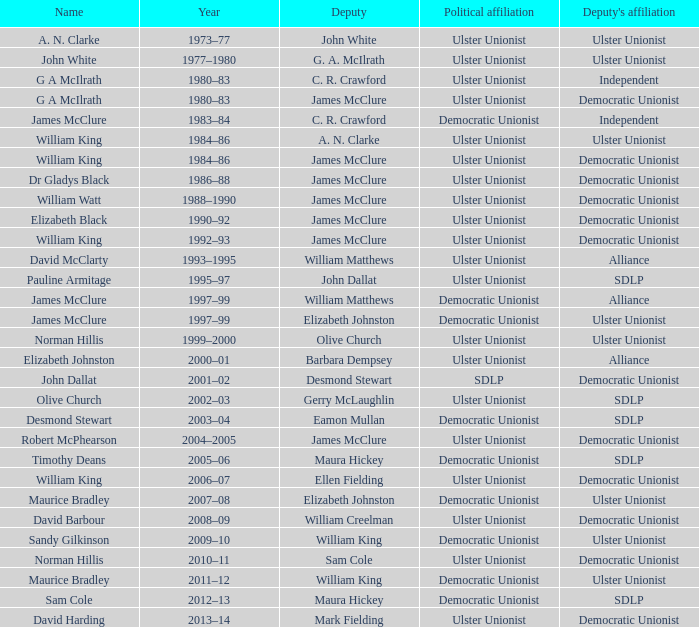What is the Name for 1997–99? James McClure, James McClure. 